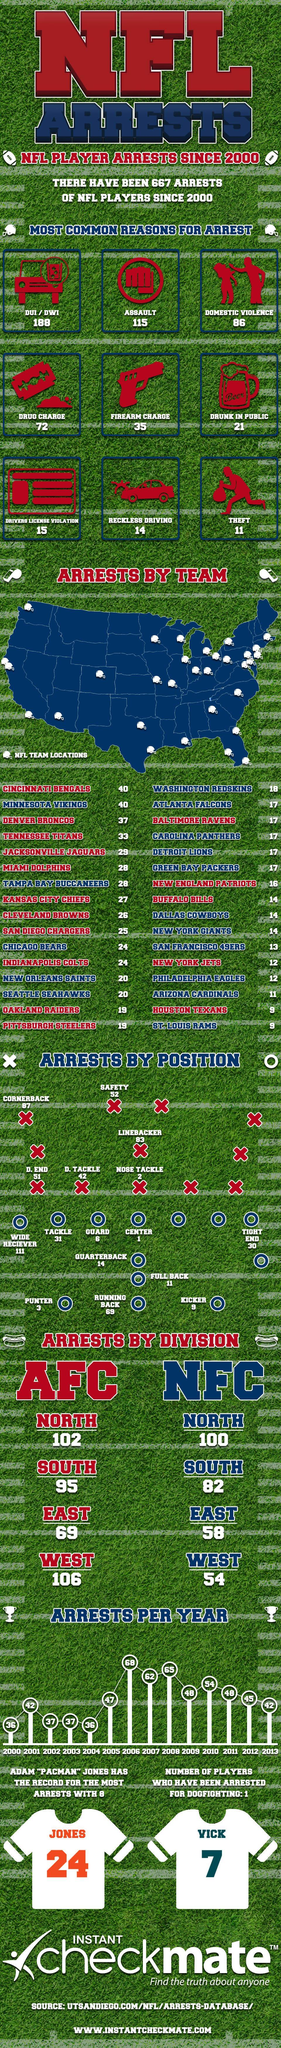How many assaults that lead to arrest
Answer the question with a short phrase. 115 What is the number written on the jersey of Jones 24 How many arrests by nose tackle 2 What is the number written on the jersey of Vick 7 WHich year has the arrest been the second highest 2008 how many common reasons have been highlighted for arrest 9 